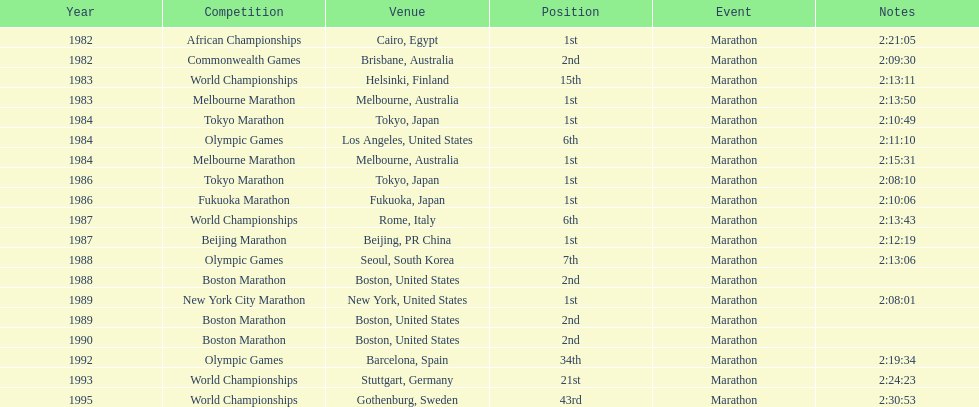How often was the venue found in the united states? 5. 